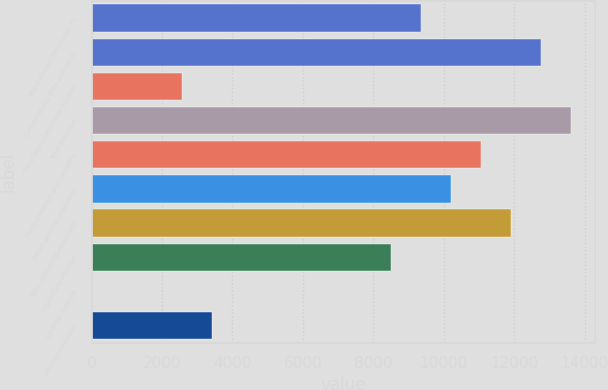<chart> <loc_0><loc_0><loc_500><loc_500><bar_chart><fcel>Years ended December 31<fcel>Commissions fees and other<fcel>Fiduciary investment income<fcel>Total revenue<fcel>Compensation and benefits<fcel>Other general expenses<fcel>Total operating expenses<fcel>Operating income<fcel>Interest income<fcel>Interest expense<nl><fcel>9361.7<fcel>12760.5<fcel>2564.1<fcel>13610.2<fcel>11061.1<fcel>10211.4<fcel>11910.8<fcel>8512<fcel>15<fcel>3413.8<nl></chart> 